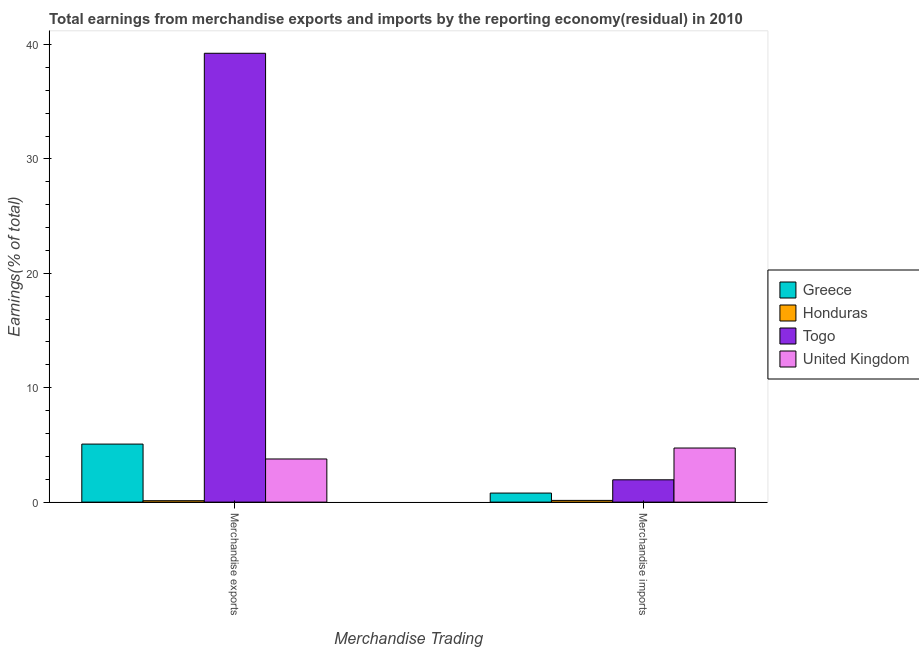How many different coloured bars are there?
Offer a very short reply. 4. Are the number of bars per tick equal to the number of legend labels?
Your response must be concise. Yes. Are the number of bars on each tick of the X-axis equal?
Your response must be concise. Yes. How many bars are there on the 2nd tick from the left?
Offer a very short reply. 4. How many bars are there on the 2nd tick from the right?
Make the answer very short. 4. What is the earnings from merchandise exports in Greece?
Your answer should be compact. 5.07. Across all countries, what is the maximum earnings from merchandise exports?
Your answer should be very brief. 39.24. Across all countries, what is the minimum earnings from merchandise exports?
Offer a terse response. 0.12. In which country was the earnings from merchandise imports minimum?
Keep it short and to the point. Honduras. What is the total earnings from merchandise imports in the graph?
Offer a very short reply. 7.62. What is the difference between the earnings from merchandise imports in United Kingdom and that in Togo?
Ensure brevity in your answer.  2.78. What is the difference between the earnings from merchandise imports in Togo and the earnings from merchandise exports in Honduras?
Provide a short and direct response. 1.83. What is the average earnings from merchandise imports per country?
Your response must be concise. 1.91. What is the difference between the earnings from merchandise imports and earnings from merchandise exports in Honduras?
Ensure brevity in your answer.  0.03. In how many countries, is the earnings from merchandise exports greater than 34 %?
Provide a short and direct response. 1. What is the ratio of the earnings from merchandise exports in Togo to that in Greece?
Your answer should be very brief. 7.73. In how many countries, is the earnings from merchandise imports greater than the average earnings from merchandise imports taken over all countries?
Provide a succinct answer. 2. What does the 3rd bar from the left in Merchandise imports represents?
Keep it short and to the point. Togo. What does the 3rd bar from the right in Merchandise imports represents?
Ensure brevity in your answer.  Honduras. How many bars are there?
Ensure brevity in your answer.  8. Are the values on the major ticks of Y-axis written in scientific E-notation?
Your answer should be very brief. No. Where does the legend appear in the graph?
Offer a terse response. Center right. How are the legend labels stacked?
Offer a very short reply. Vertical. What is the title of the graph?
Your answer should be very brief. Total earnings from merchandise exports and imports by the reporting economy(residual) in 2010. What is the label or title of the X-axis?
Make the answer very short. Merchandise Trading. What is the label or title of the Y-axis?
Offer a terse response. Earnings(% of total). What is the Earnings(% of total) in Greece in Merchandise exports?
Your answer should be compact. 5.07. What is the Earnings(% of total) of Honduras in Merchandise exports?
Offer a terse response. 0.12. What is the Earnings(% of total) in Togo in Merchandise exports?
Provide a succinct answer. 39.24. What is the Earnings(% of total) of United Kingdom in Merchandise exports?
Your answer should be compact. 3.77. What is the Earnings(% of total) of Greece in Merchandise imports?
Give a very brief answer. 0.79. What is the Earnings(% of total) in Honduras in Merchandise imports?
Provide a short and direct response. 0.15. What is the Earnings(% of total) in Togo in Merchandise imports?
Provide a succinct answer. 1.95. What is the Earnings(% of total) in United Kingdom in Merchandise imports?
Keep it short and to the point. 4.73. Across all Merchandise Trading, what is the maximum Earnings(% of total) in Greece?
Provide a short and direct response. 5.07. Across all Merchandise Trading, what is the maximum Earnings(% of total) in Honduras?
Keep it short and to the point. 0.15. Across all Merchandise Trading, what is the maximum Earnings(% of total) of Togo?
Ensure brevity in your answer.  39.24. Across all Merchandise Trading, what is the maximum Earnings(% of total) in United Kingdom?
Your answer should be compact. 4.73. Across all Merchandise Trading, what is the minimum Earnings(% of total) of Greece?
Offer a terse response. 0.79. Across all Merchandise Trading, what is the minimum Earnings(% of total) of Honduras?
Offer a very short reply. 0.12. Across all Merchandise Trading, what is the minimum Earnings(% of total) in Togo?
Offer a very short reply. 1.95. Across all Merchandise Trading, what is the minimum Earnings(% of total) of United Kingdom?
Give a very brief answer. 3.77. What is the total Earnings(% of total) of Greece in the graph?
Your answer should be compact. 5.87. What is the total Earnings(% of total) of Honduras in the graph?
Your answer should be compact. 0.28. What is the total Earnings(% of total) in Togo in the graph?
Make the answer very short. 41.19. What is the total Earnings(% of total) in United Kingdom in the graph?
Your response must be concise. 8.5. What is the difference between the Earnings(% of total) of Greece in Merchandise exports and that in Merchandise imports?
Give a very brief answer. 4.28. What is the difference between the Earnings(% of total) in Honduras in Merchandise exports and that in Merchandise imports?
Your response must be concise. -0.03. What is the difference between the Earnings(% of total) of Togo in Merchandise exports and that in Merchandise imports?
Your answer should be compact. 37.29. What is the difference between the Earnings(% of total) in United Kingdom in Merchandise exports and that in Merchandise imports?
Give a very brief answer. -0.96. What is the difference between the Earnings(% of total) of Greece in Merchandise exports and the Earnings(% of total) of Honduras in Merchandise imports?
Make the answer very short. 4.92. What is the difference between the Earnings(% of total) of Greece in Merchandise exports and the Earnings(% of total) of Togo in Merchandise imports?
Provide a succinct answer. 3.12. What is the difference between the Earnings(% of total) in Greece in Merchandise exports and the Earnings(% of total) in United Kingdom in Merchandise imports?
Offer a very short reply. 0.34. What is the difference between the Earnings(% of total) of Honduras in Merchandise exports and the Earnings(% of total) of Togo in Merchandise imports?
Your response must be concise. -1.83. What is the difference between the Earnings(% of total) of Honduras in Merchandise exports and the Earnings(% of total) of United Kingdom in Merchandise imports?
Your answer should be very brief. -4.6. What is the difference between the Earnings(% of total) of Togo in Merchandise exports and the Earnings(% of total) of United Kingdom in Merchandise imports?
Give a very brief answer. 34.51. What is the average Earnings(% of total) of Greece per Merchandise Trading?
Keep it short and to the point. 2.93. What is the average Earnings(% of total) of Honduras per Merchandise Trading?
Provide a short and direct response. 0.14. What is the average Earnings(% of total) in Togo per Merchandise Trading?
Your answer should be very brief. 20.59. What is the average Earnings(% of total) in United Kingdom per Merchandise Trading?
Keep it short and to the point. 4.25. What is the difference between the Earnings(% of total) of Greece and Earnings(% of total) of Honduras in Merchandise exports?
Provide a succinct answer. 4.95. What is the difference between the Earnings(% of total) of Greece and Earnings(% of total) of Togo in Merchandise exports?
Ensure brevity in your answer.  -34.16. What is the difference between the Earnings(% of total) of Greece and Earnings(% of total) of United Kingdom in Merchandise exports?
Give a very brief answer. 1.3. What is the difference between the Earnings(% of total) in Honduras and Earnings(% of total) in Togo in Merchandise exports?
Offer a very short reply. -39.11. What is the difference between the Earnings(% of total) in Honduras and Earnings(% of total) in United Kingdom in Merchandise exports?
Give a very brief answer. -3.65. What is the difference between the Earnings(% of total) in Togo and Earnings(% of total) in United Kingdom in Merchandise exports?
Give a very brief answer. 35.46. What is the difference between the Earnings(% of total) in Greece and Earnings(% of total) in Honduras in Merchandise imports?
Your answer should be very brief. 0.64. What is the difference between the Earnings(% of total) in Greece and Earnings(% of total) in Togo in Merchandise imports?
Offer a very short reply. -1.16. What is the difference between the Earnings(% of total) of Greece and Earnings(% of total) of United Kingdom in Merchandise imports?
Your response must be concise. -3.94. What is the difference between the Earnings(% of total) in Honduras and Earnings(% of total) in Togo in Merchandise imports?
Make the answer very short. -1.8. What is the difference between the Earnings(% of total) in Honduras and Earnings(% of total) in United Kingdom in Merchandise imports?
Keep it short and to the point. -4.58. What is the difference between the Earnings(% of total) in Togo and Earnings(% of total) in United Kingdom in Merchandise imports?
Ensure brevity in your answer.  -2.78. What is the ratio of the Earnings(% of total) of Greece in Merchandise exports to that in Merchandise imports?
Your response must be concise. 6.41. What is the ratio of the Earnings(% of total) of Honduras in Merchandise exports to that in Merchandise imports?
Keep it short and to the point. 0.82. What is the ratio of the Earnings(% of total) in Togo in Merchandise exports to that in Merchandise imports?
Provide a succinct answer. 20.11. What is the ratio of the Earnings(% of total) in United Kingdom in Merchandise exports to that in Merchandise imports?
Offer a very short reply. 0.8. What is the difference between the highest and the second highest Earnings(% of total) of Greece?
Keep it short and to the point. 4.28. What is the difference between the highest and the second highest Earnings(% of total) in Honduras?
Provide a short and direct response. 0.03. What is the difference between the highest and the second highest Earnings(% of total) of Togo?
Provide a short and direct response. 37.29. What is the difference between the highest and the second highest Earnings(% of total) of United Kingdom?
Ensure brevity in your answer.  0.96. What is the difference between the highest and the lowest Earnings(% of total) in Greece?
Give a very brief answer. 4.28. What is the difference between the highest and the lowest Earnings(% of total) in Honduras?
Make the answer very short. 0.03. What is the difference between the highest and the lowest Earnings(% of total) of Togo?
Offer a very short reply. 37.29. What is the difference between the highest and the lowest Earnings(% of total) of United Kingdom?
Your answer should be compact. 0.96. 